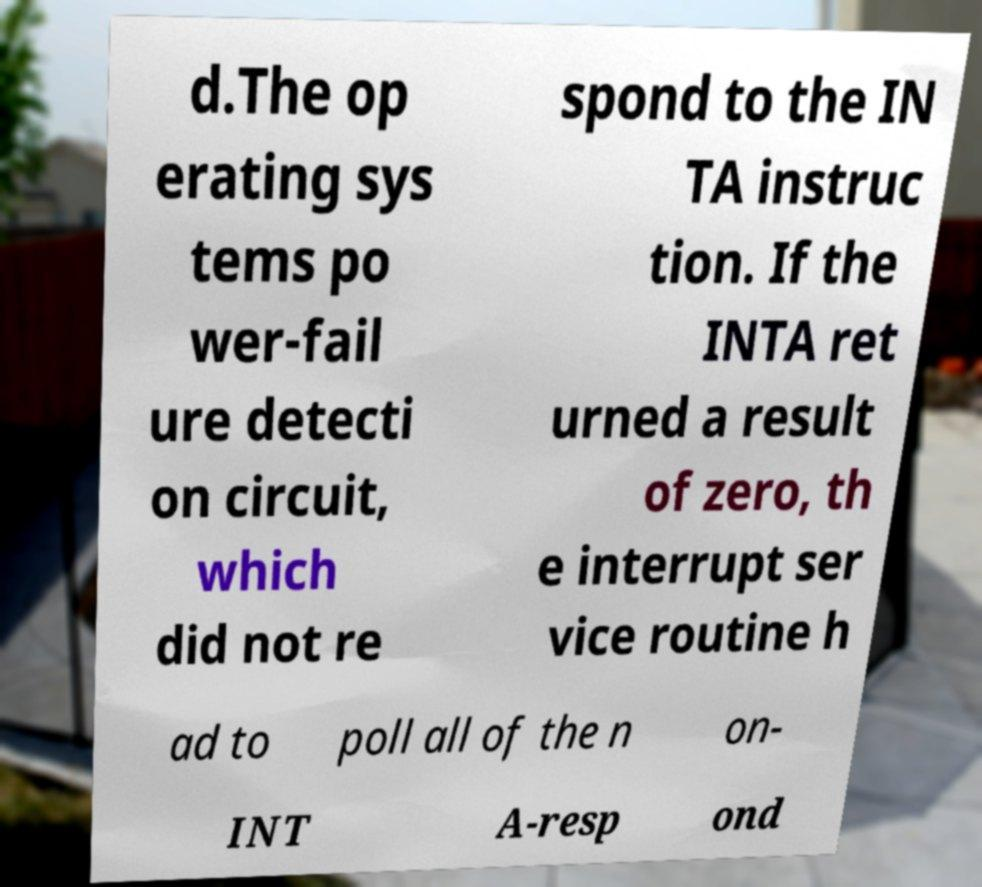Could you extract and type out the text from this image? d.The op erating sys tems po wer-fail ure detecti on circuit, which did not re spond to the IN TA instruc tion. If the INTA ret urned a result of zero, th e interrupt ser vice routine h ad to poll all of the n on- INT A-resp ond 